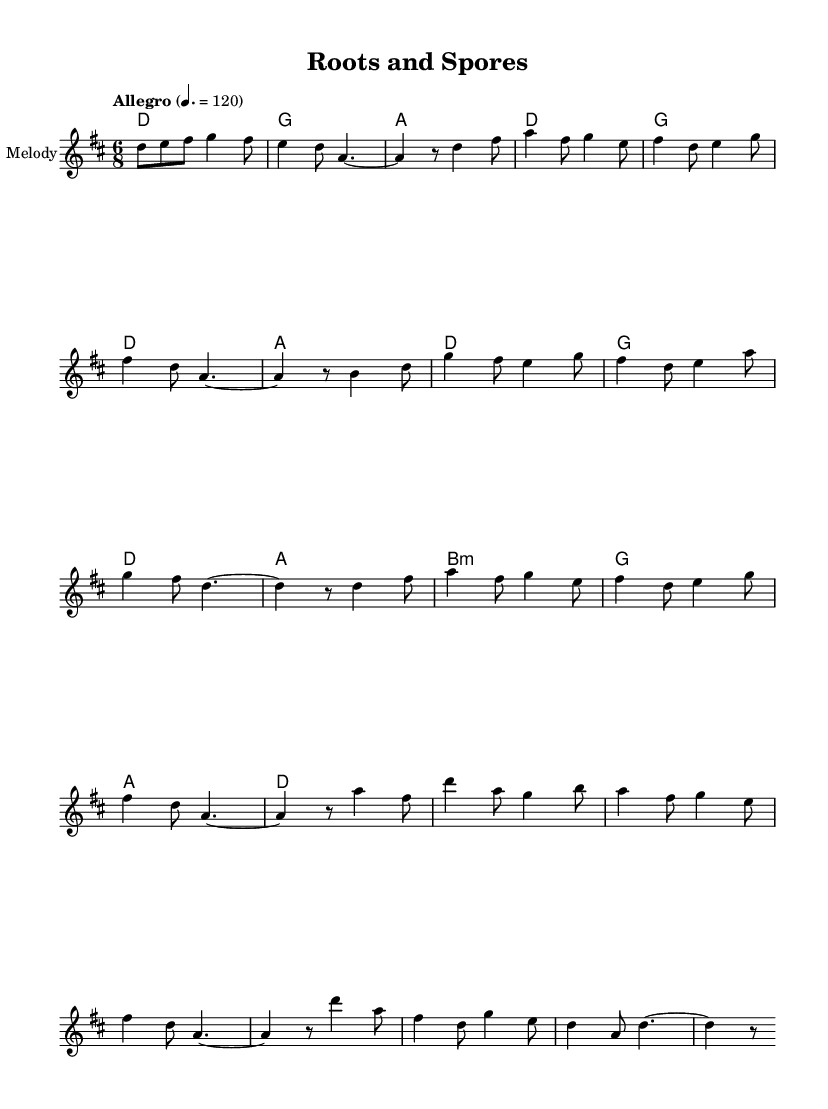What is the key signature of this music? The key signature is D major, which has two sharps: F# and C#.
Answer: D major What is the time signature of the piece? The time signature is 6/8, indicating six eighth notes per measure.
Answer: 6/8 What is the tempo marking provided in the score? The tempo marking states "Allegro", which indicates a fast and lively pace, with a metronome marking of 120 beats per minute.
Answer: Allegro How many sections are there in the melody? The melody consists of four distinct sections labeled as Intro, A, B, and C.
Answer: Four In which measure does section B begin? Section B begins in measure 9, immediately following the first repetition of section A.
Answer: Measure 9 How many chords are used in the harmony section? There are eight different chords presented in the harmony section, corresponding to the melody's rhythmic structure.
Answer: Eight What is the last note in the melody? The last note in the melody is a D, which concludes the piece on its tonic note in a stable manner.
Answer: D 